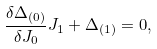Convert formula to latex. <formula><loc_0><loc_0><loc_500><loc_500>\frac { \delta \Delta _ { ( 0 ) } } { \delta J _ { 0 } } J _ { 1 } + \Delta _ { ( 1 ) } = 0 ,</formula> 